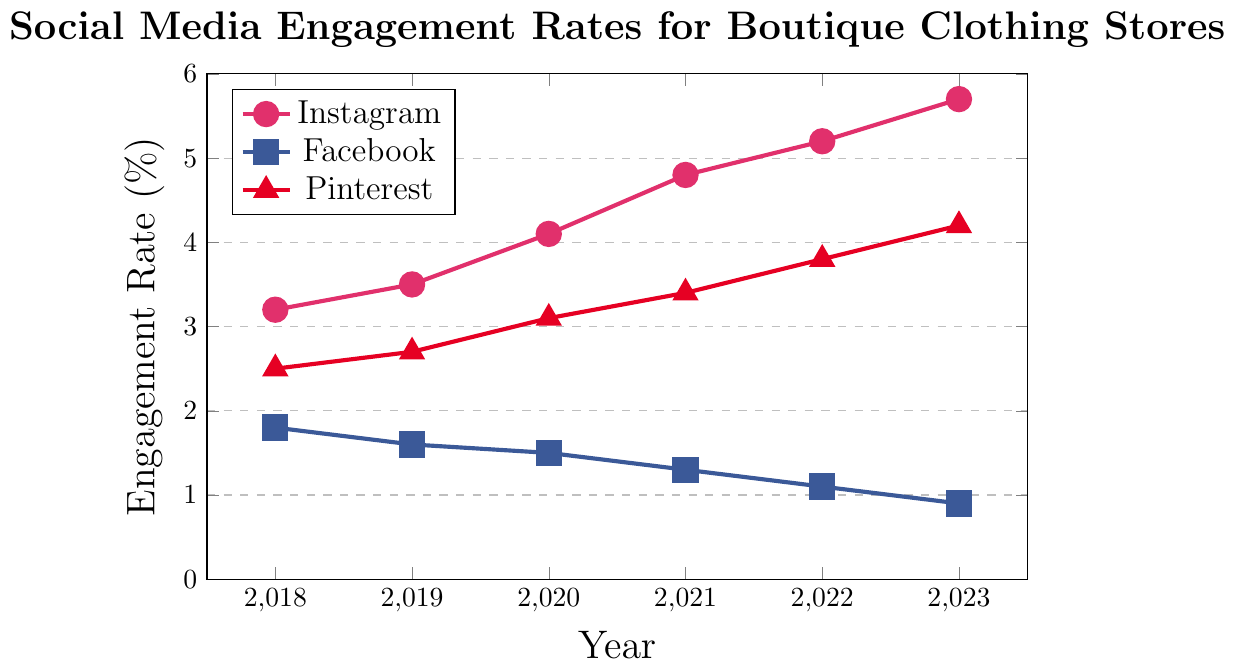What is the overall trend for Instagram engagement rates from 2018 to 2023? The Instagram engagement rates are represented by a line with circular markers. Observing this line, it consistently rises over the years from 3.2% in 2018 to 5.7% in 2023.
Answer: Increasing Between which two consecutive years did Pinterest see the largest increase in engagement rates? Looking at the triangle-marked line for Pinterest, you compare the differences between the years: 0.2% (2018-2019), 0.4% (2019-2020), 0.3% (2020-2021), 0.4% (2021-2022), 0.4% (2022-2023). The largest difference is between 2022 and 2023, 2021 and 2022, and 2022 and 2023 with an increase of 0.4%.
Answer: 2019 to 2020, 2021 to 2022, 2022 to 2023 Which platform had the lowest engagement rate in 2023? Observing the end points for 2023 on the lines marked for Instagram, Facebook, and Pinterest, Facebook's line ends at the lowest point, which is 0.9%.
Answer: Facebook How did the Facebook engagement rate change from 2018 to 2023? The Facebook engagement rates are represented by the square-marked line. It shows a steady decrease from 1.8% in 2018 to 0.9% in 2023.
Answer: Decreasing What was the engagement rate for Pinterest in 2021 and was it higher or lower than that of Facebook in the same year? The engagement rate for Pinterest in 2021 was 3.4%, indicated by the triangle marker. The engagement rate for Facebook in 2021, indicated by the square marker, is 1.3%. Comparing these, Pinterest's rate is higher.
Answer: 3.4%, higher Which social media platform had the highest engagement rate in 2020? By comparing the markers for 2020 on the lines for Instagram, Facebook, and Pinterest, Instagram has the highest engagement rate at 4.1%.
Answer: Instagram Calculate the average engagement rate for Pinterest over the six years provided. Add the engagement rates for Pinterest from 2018 to 2023: 2.5% + 2.7% + 3.1% + 3.4% + 3.8% + 4.2% = 19.7%. Then divide by 6 to find the average: 19.7% / 6 = 3.28%.
Answer: 3.28% Which platform showed the most consistent trend over the years, and what was that trend? The Facebook engagement rate, marked by squares, shows a consistent downward trend every year from 2018 to 2023.
Answer: Facebook, decreasing 